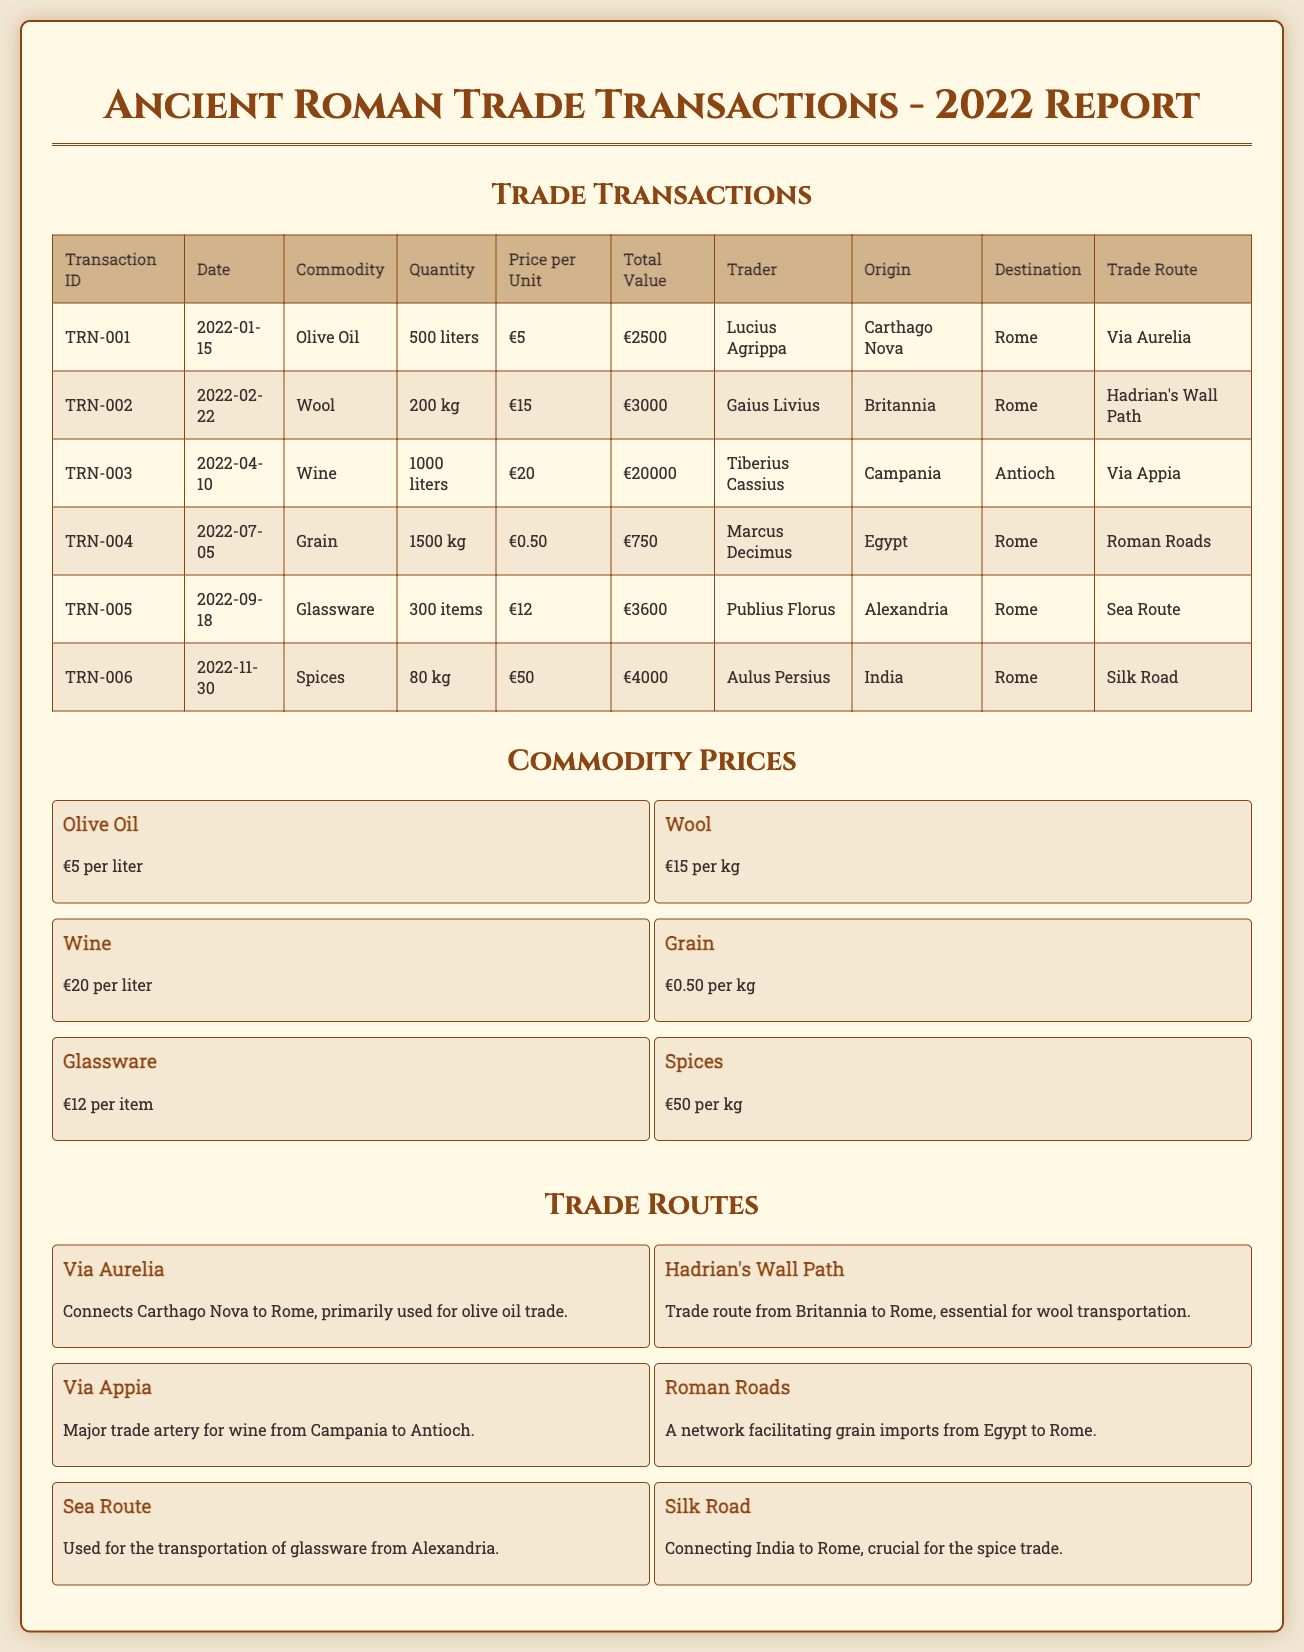What is the total value of the olive oil transaction? The total value is directly specified in the transaction for olive oil as €2500.
Answer: €2500 Who is the trader for the grain transaction? The trader is identified in the grain transaction as Marcus Decimus.
Answer: Marcus Decimus What is the price per unit of spices? The price per unit of spices is stated as €50 per kg in the commodity prices section.
Answer: €50 per kg Which trade route is used for transporting glassware? The document mentions that the glassware is transported via the Sea Route.
Answer: Sea Route What date was the wine transaction made? The date of the wine transaction is listed as 2022-04-10 in the transaction table.
Answer: 2022-04-10 How much wool was traded in the transaction? The quantity of wool traded is specified as 200 kg in the transaction details.
Answer: 200 kg What is the origin of the spices transaction? The origin of the spices is listed as India in the transaction report.
Answer: India How many items of glassware were traded? The number of glassware items traded is clearly stated as 300 items in the transaction table.
Answer: 300 items Which commodity had the highest total value in the transactions? The wine transaction had the highest total value at €20000, as indicated in the report.
Answer: €20000 